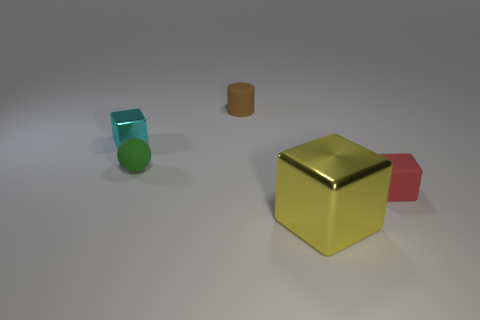Add 4 small cylinders. How many objects exist? 9 Subtract all cubes. How many objects are left? 2 Subtract all yellow rubber cylinders. Subtract all small red matte things. How many objects are left? 4 Add 5 brown cylinders. How many brown cylinders are left? 6 Add 5 small brown rubber objects. How many small brown rubber objects exist? 6 Subtract 0 green blocks. How many objects are left? 5 